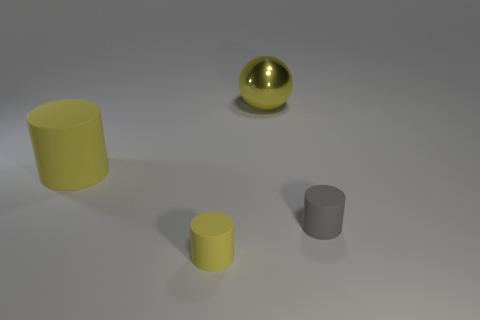There is a tiny cylinder that is the same color as the big sphere; what is it made of?
Provide a short and direct response. Rubber. Are there any metallic things of the same size as the gray cylinder?
Ensure brevity in your answer.  No. Is there a shiny block that has the same color as the sphere?
Your response must be concise. No. Is there any other thing that has the same size as the gray cylinder?
Make the answer very short. Yes. How many small rubber objects are the same color as the large matte object?
Offer a very short reply. 1. Do the big matte cylinder and the tiny matte cylinder to the left of the large yellow ball have the same color?
Make the answer very short. Yes. How many objects are cyan metal cylinders or large yellow objects that are in front of the large shiny thing?
Make the answer very short. 1. What size is the yellow cylinder that is behind the tiny object left of the large yellow metal ball?
Your answer should be compact. Large. Are there an equal number of tiny cylinders that are to the right of the big shiny object and yellow rubber things that are in front of the small yellow object?
Offer a terse response. No. Are there any yellow matte cylinders that are in front of the gray thing on the right side of the ball?
Provide a short and direct response. Yes. 